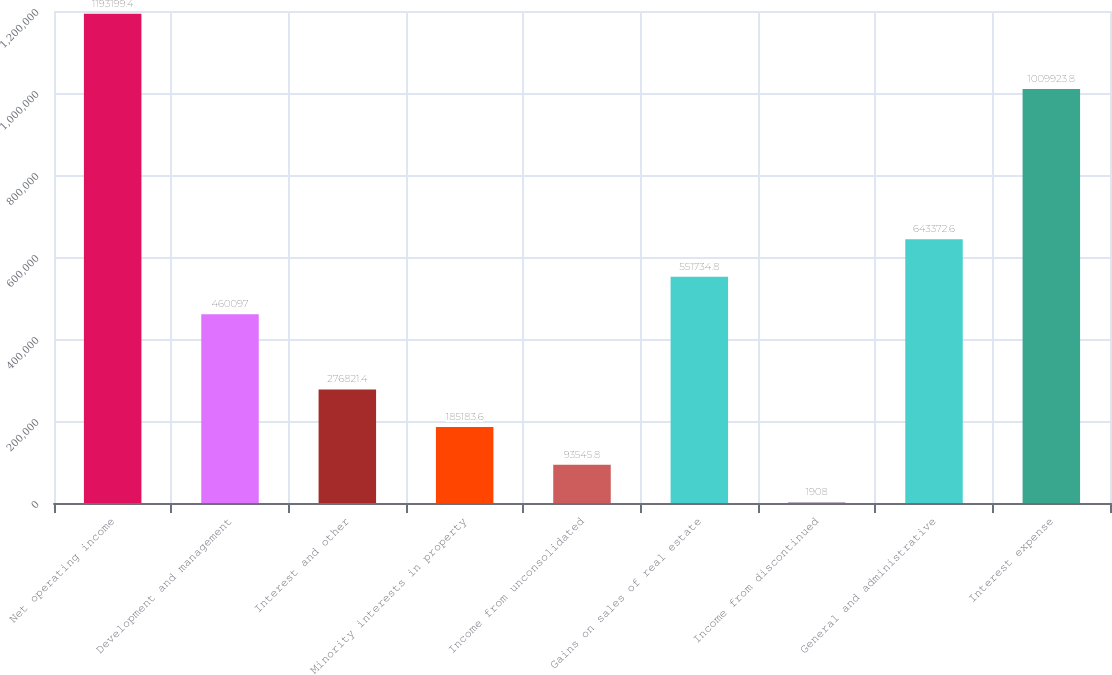<chart> <loc_0><loc_0><loc_500><loc_500><bar_chart><fcel>Net operating income<fcel>Development and management<fcel>Interest and other<fcel>Minority interests in property<fcel>Income from unconsolidated<fcel>Gains on sales of real estate<fcel>Income from discontinued<fcel>General and administrative<fcel>Interest expense<nl><fcel>1.1932e+06<fcel>460097<fcel>276821<fcel>185184<fcel>93545.8<fcel>551735<fcel>1908<fcel>643373<fcel>1.00992e+06<nl></chart> 